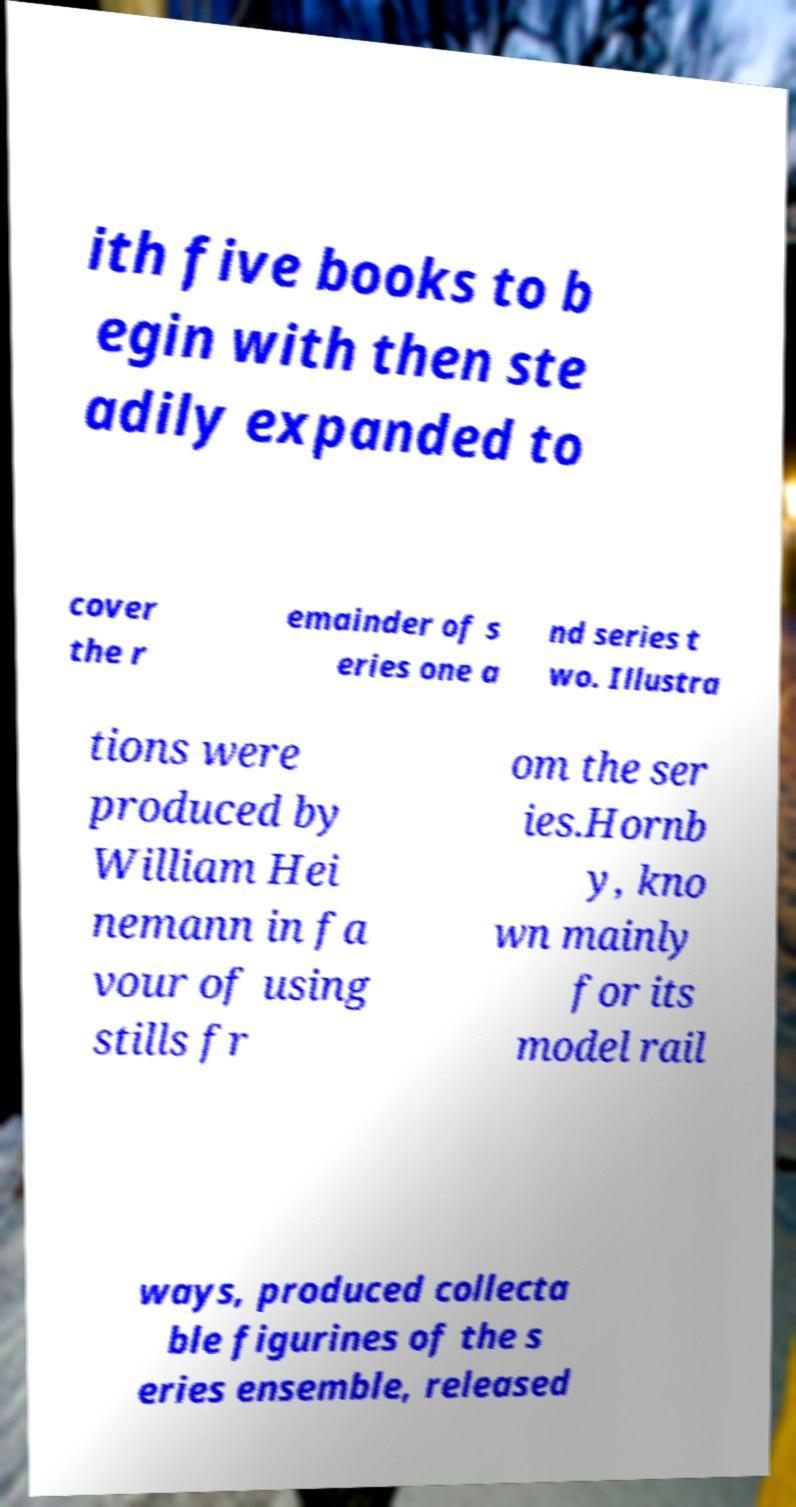Can you read and provide the text displayed in the image?This photo seems to have some interesting text. Can you extract and type it out for me? ith five books to b egin with then ste adily expanded to cover the r emainder of s eries one a nd series t wo. Illustra tions were produced by William Hei nemann in fa vour of using stills fr om the ser ies.Hornb y, kno wn mainly for its model rail ways, produced collecta ble figurines of the s eries ensemble, released 